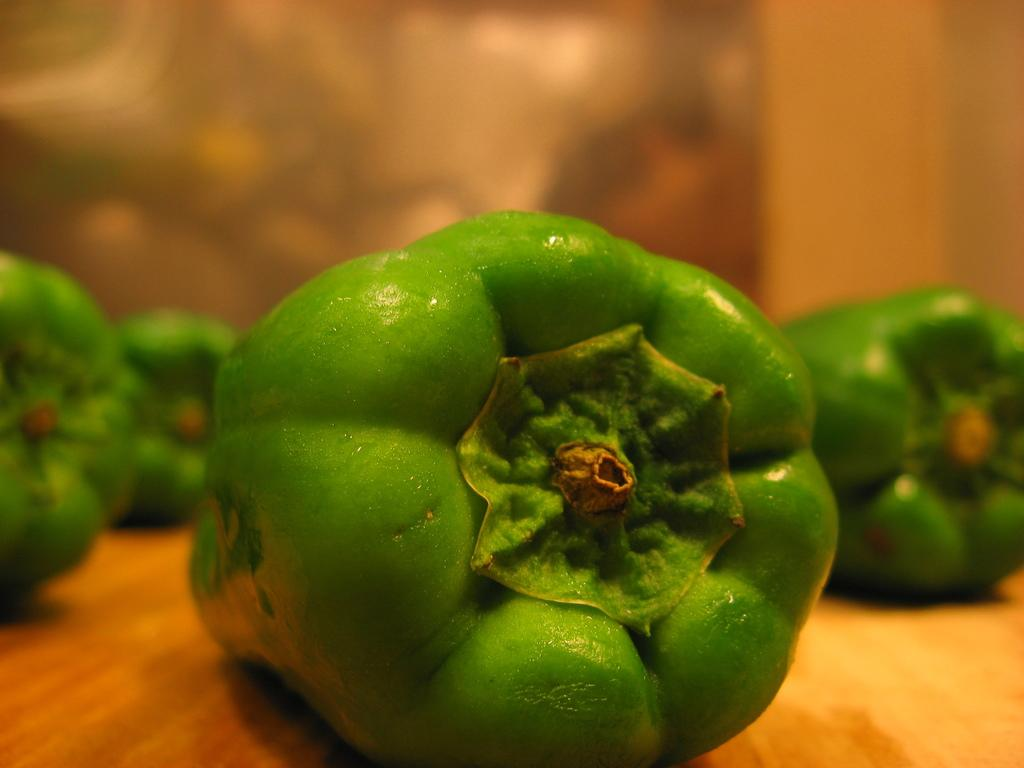What type of food can be seen in the image? There are vegetables placed on a surface in the image. Can you describe the background of the image? The background of the image is blurry. What type of fruit is present in the image? There is no fruit present in the image; it only features vegetables. Can you identify any circular shapes in the image? The image does not show any circular shapes; it only features vegetables and a blurry background. 